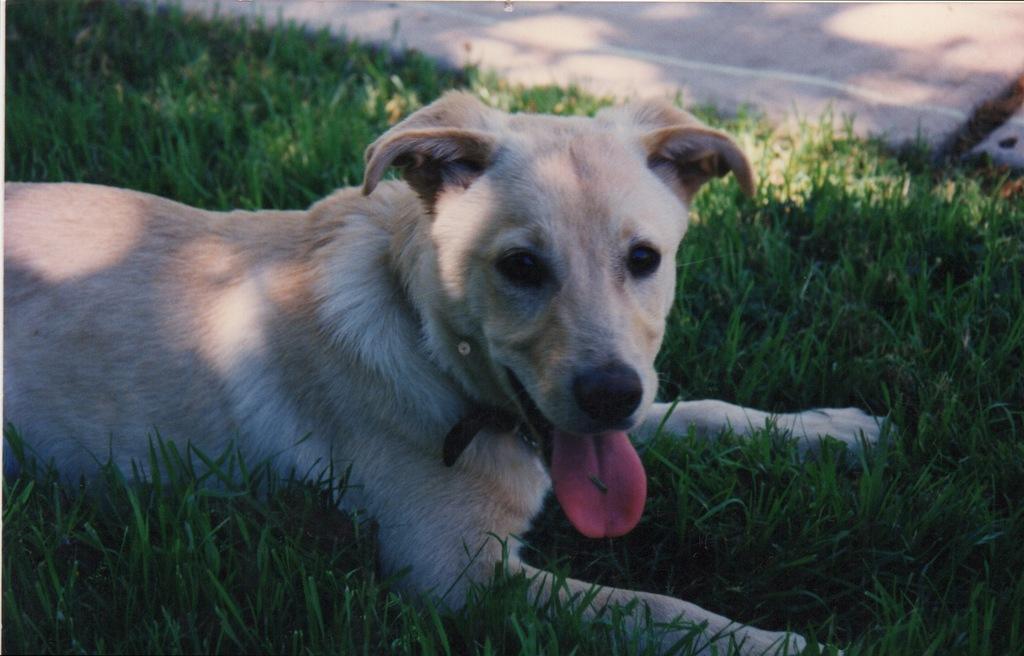Could you give a brief overview of what you see in this image? In this image we can see a dog, grass and also the road. 